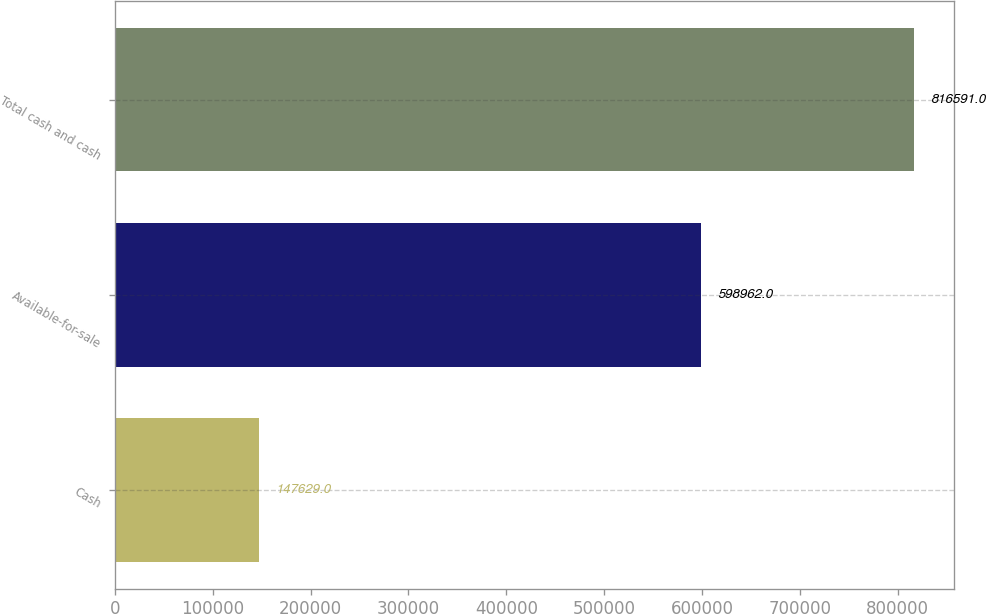<chart> <loc_0><loc_0><loc_500><loc_500><bar_chart><fcel>Cash<fcel>Available-for-sale<fcel>Total cash and cash<nl><fcel>147629<fcel>598962<fcel>816591<nl></chart> 